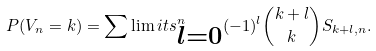Convert formula to latex. <formula><loc_0><loc_0><loc_500><loc_500>P ( V _ { n } = k ) = \sum \lim i t s ^ { n } _ { \substack { l = 0 } } ( - 1 ) ^ { l } \binom { k + l } { k } S _ { k + l , n } .</formula> 